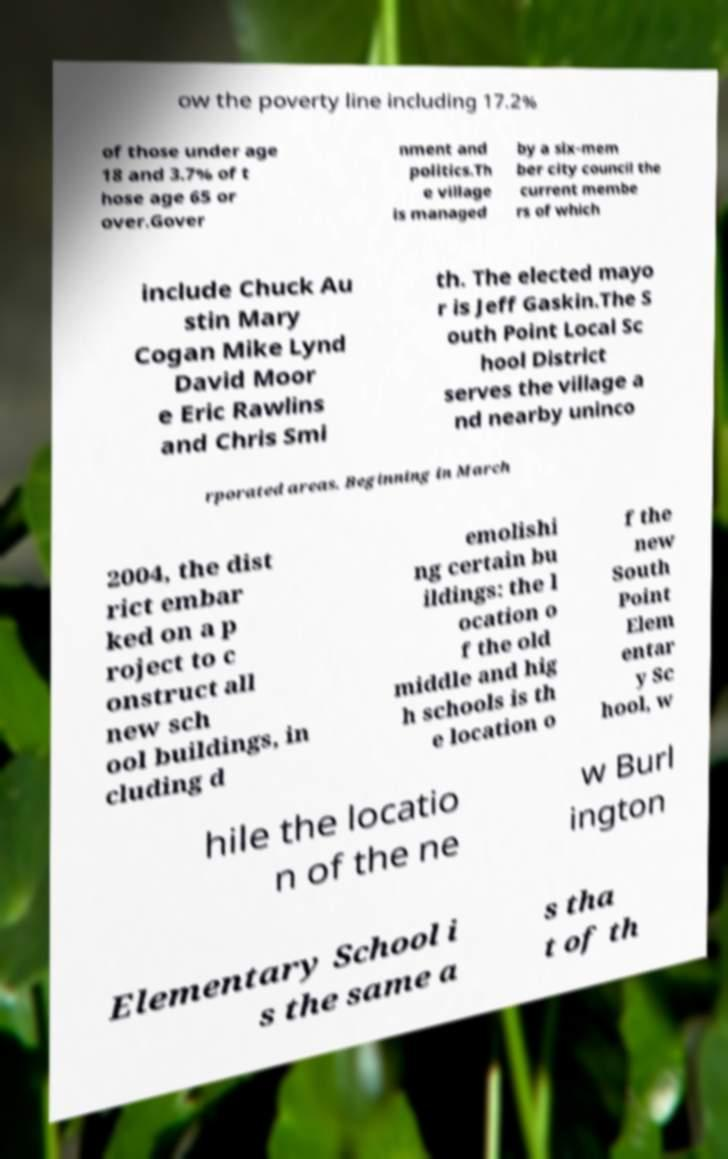Please read and relay the text visible in this image. What does it say? ow the poverty line including 17.2% of those under age 18 and 3.7% of t hose age 65 or over.Gover nment and politics.Th e village is managed by a six-mem ber city council the current membe rs of which include Chuck Au stin Mary Cogan Mike Lynd David Moor e Eric Rawlins and Chris Smi th. The elected mayo r is Jeff Gaskin.The S outh Point Local Sc hool District serves the village a nd nearby uninco rporated areas. Beginning in March 2004, the dist rict embar ked on a p roject to c onstruct all new sch ool buildings, in cluding d emolishi ng certain bu ildings: the l ocation o f the old middle and hig h schools is th e location o f the new South Point Elem entar y Sc hool, w hile the locatio n of the ne w Burl ington Elementary School i s the same a s tha t of th 